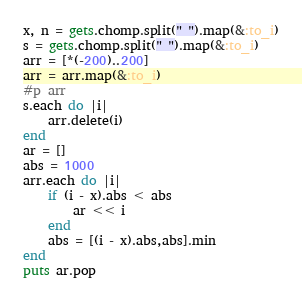Convert code to text. <code><loc_0><loc_0><loc_500><loc_500><_Ruby_>x, n = gets.chomp.split(" ").map(&:to_i)
s = gets.chomp.split(" ").map(&:to_i)
arr = [*(-200)..200]
arr = arr.map(&:to_i)
#p arr
s.each do |i|
    arr.delete(i)
end
ar = []
abs = 1000
arr.each do |i|
    if (i - x).abs < abs
        ar << i
    end
    abs = [(i - x).abs,abs].min
end
puts ar.pop</code> 